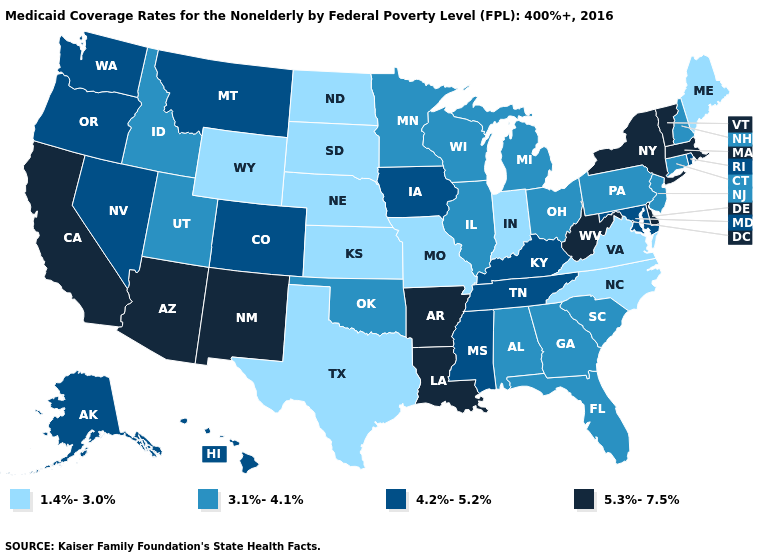Does Maryland have a lower value than Missouri?
Keep it brief. No. Does Nebraska have the lowest value in the MidWest?
Keep it brief. Yes. How many symbols are there in the legend?
Keep it brief. 4. Among the states that border Massachusetts , which have the lowest value?
Keep it brief. Connecticut, New Hampshire. Name the states that have a value in the range 4.2%-5.2%?
Short answer required. Alaska, Colorado, Hawaii, Iowa, Kentucky, Maryland, Mississippi, Montana, Nevada, Oregon, Rhode Island, Tennessee, Washington. What is the value of South Carolina?
Give a very brief answer. 3.1%-4.1%. Does North Dakota have a lower value than Florida?
Concise answer only. Yes. Among the states that border Mississippi , which have the highest value?
Be succinct. Arkansas, Louisiana. Which states have the lowest value in the South?
Be succinct. North Carolina, Texas, Virginia. What is the value of Illinois?
Keep it brief. 3.1%-4.1%. Name the states that have a value in the range 3.1%-4.1%?
Answer briefly. Alabama, Connecticut, Florida, Georgia, Idaho, Illinois, Michigan, Minnesota, New Hampshire, New Jersey, Ohio, Oklahoma, Pennsylvania, South Carolina, Utah, Wisconsin. What is the value of West Virginia?
Concise answer only. 5.3%-7.5%. Name the states that have a value in the range 4.2%-5.2%?
Be succinct. Alaska, Colorado, Hawaii, Iowa, Kentucky, Maryland, Mississippi, Montana, Nevada, Oregon, Rhode Island, Tennessee, Washington. Does the map have missing data?
Answer briefly. No. Which states hav the highest value in the MidWest?
Concise answer only. Iowa. 